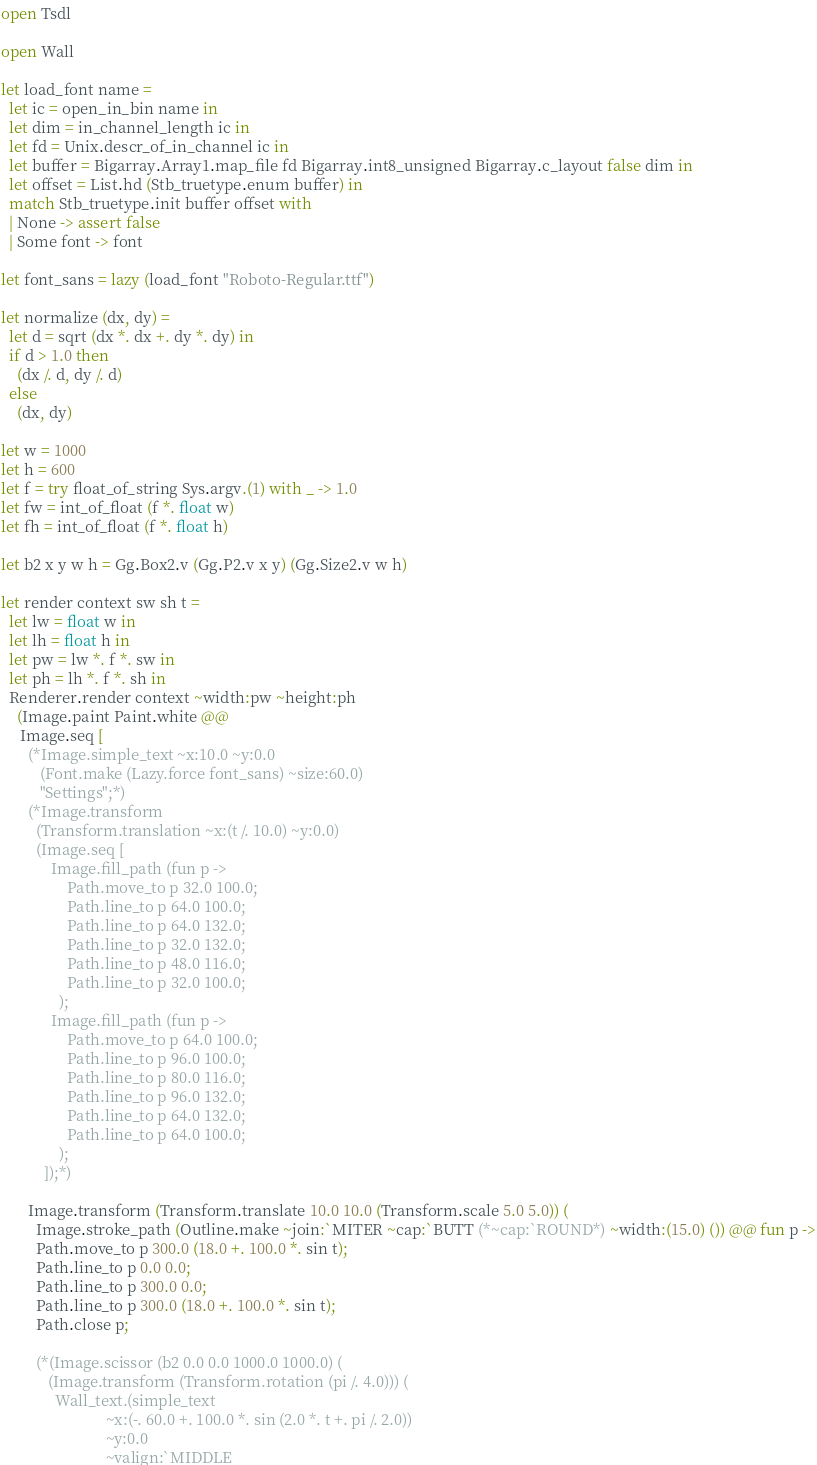Convert code to text. <code><loc_0><loc_0><loc_500><loc_500><_OCaml_>open Tsdl

open Wall

let load_font name =
  let ic = open_in_bin name in
  let dim = in_channel_length ic in
  let fd = Unix.descr_of_in_channel ic in
  let buffer = Bigarray.Array1.map_file fd Bigarray.int8_unsigned Bigarray.c_layout false dim in
  let offset = List.hd (Stb_truetype.enum buffer) in
  match Stb_truetype.init buffer offset with
  | None -> assert false
  | Some font -> font

let font_sans = lazy (load_font "Roboto-Regular.ttf")

let normalize (dx, dy) =
  let d = sqrt (dx *. dx +. dy *. dy) in
  if d > 1.0 then
    (dx /. d, dy /. d)
  else
    (dx, dy)

let w = 1000
let h = 600
let f = try float_of_string Sys.argv.(1) with _ -> 1.0
let fw = int_of_float (f *. float w)
let fh = int_of_float (f *. float h)

let b2 x y w h = Gg.Box2.v (Gg.P2.v x y) (Gg.Size2.v w h)

let render context sw sh t =
  let lw = float w in
  let lh = float h in
  let pw = lw *. f *. sw in
  let ph = lh *. f *. sh in
  Renderer.render context ~width:pw ~height:ph
    (Image.paint Paint.white @@
     Image.seq [
       (*Image.simple_text ~x:10.0 ~y:0.0
          (Font.make (Lazy.force font_sans) ~size:60.0)
          "Settings";*)
       (*Image.transform
         (Transform.translation ~x:(t /. 10.0) ~y:0.0)
         (Image.seq [
             Image.fill_path (fun p ->
                 Path.move_to p 32.0 100.0;
                 Path.line_to p 64.0 100.0;
                 Path.line_to p 64.0 132.0;
                 Path.line_to p 32.0 132.0;
                 Path.line_to p 48.0 116.0;
                 Path.line_to p 32.0 100.0;
               );
             Image.fill_path (fun p ->
                 Path.move_to p 64.0 100.0;
                 Path.line_to p 96.0 100.0;
                 Path.line_to p 80.0 116.0;
                 Path.line_to p 96.0 132.0;
                 Path.line_to p 64.0 132.0;
                 Path.line_to p 64.0 100.0;
               );
           ]);*)

       Image.transform (Transform.translate 10.0 10.0 (Transform.scale 5.0 5.0)) (
         Image.stroke_path (Outline.make ~join:`MITER ~cap:`BUTT (*~cap:`ROUND*) ~width:(15.0) ()) @@ fun p ->
         Path.move_to p 300.0 (18.0 +. 100.0 *. sin t);
         Path.line_to p 0.0 0.0;
         Path.line_to p 300.0 0.0;
         Path.line_to p 300.0 (18.0 +. 100.0 *. sin t);
         Path.close p;

         (*(Image.scissor (b2 0.0 0.0 1000.0 1000.0) (
            (Image.transform (Transform.rotation (pi /. 4.0))) (
              Wall_text.(simple_text
                           ~x:(-. 60.0 +. 100.0 *. sin (2.0 *. t +. pi /. 2.0))
                           ~y:0.0
                           ~valign:`MIDDLE</code> 